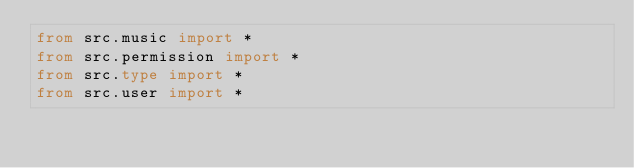Convert code to text. <code><loc_0><loc_0><loc_500><loc_500><_Python_>from src.music import *
from src.permission import *
from src.type import *
from src.user import *</code> 